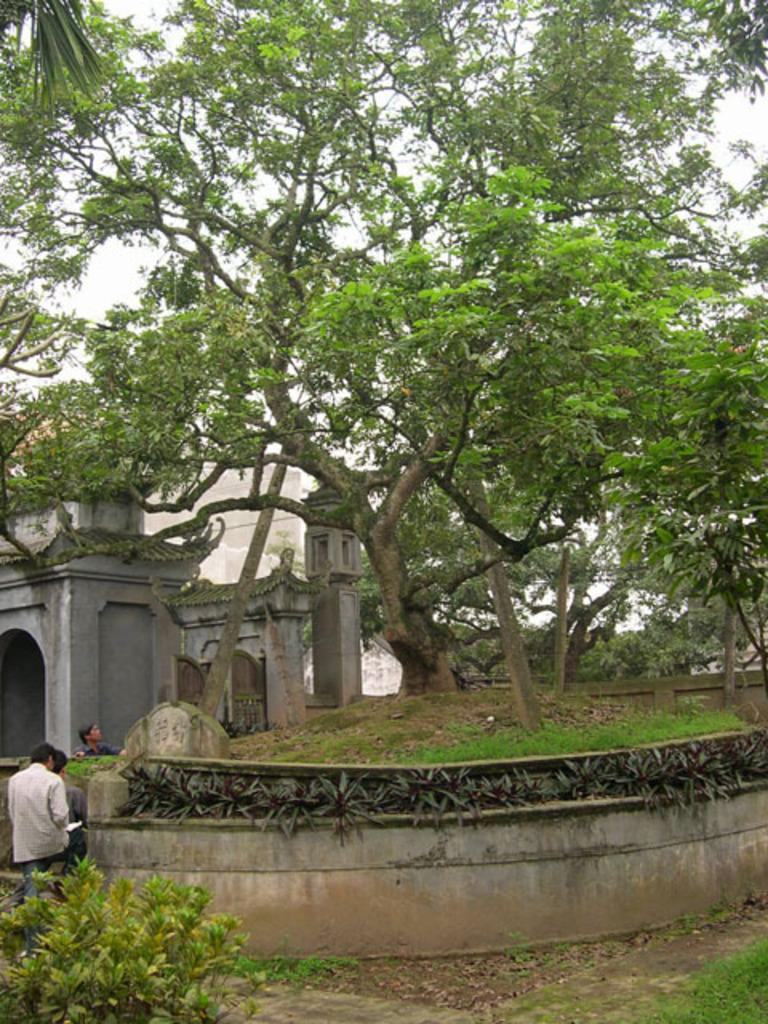What type of vegetation can be seen in the image? There are plants, green grass, and trees visible in the image. What type of environment is depicted in the image? The image shows a natural environment with vegetation and architecture. How many people are present in the image? There are three persons in the image. What is visible in the sky in the image? The sky is visible in the image. What type of glass is being used to create the bridge in the image? There is no bridge present in the image, so there is no glass being used for it. What shape is the glass in the image? There is no glass present in the image, so it is not possible to determine its shape. 